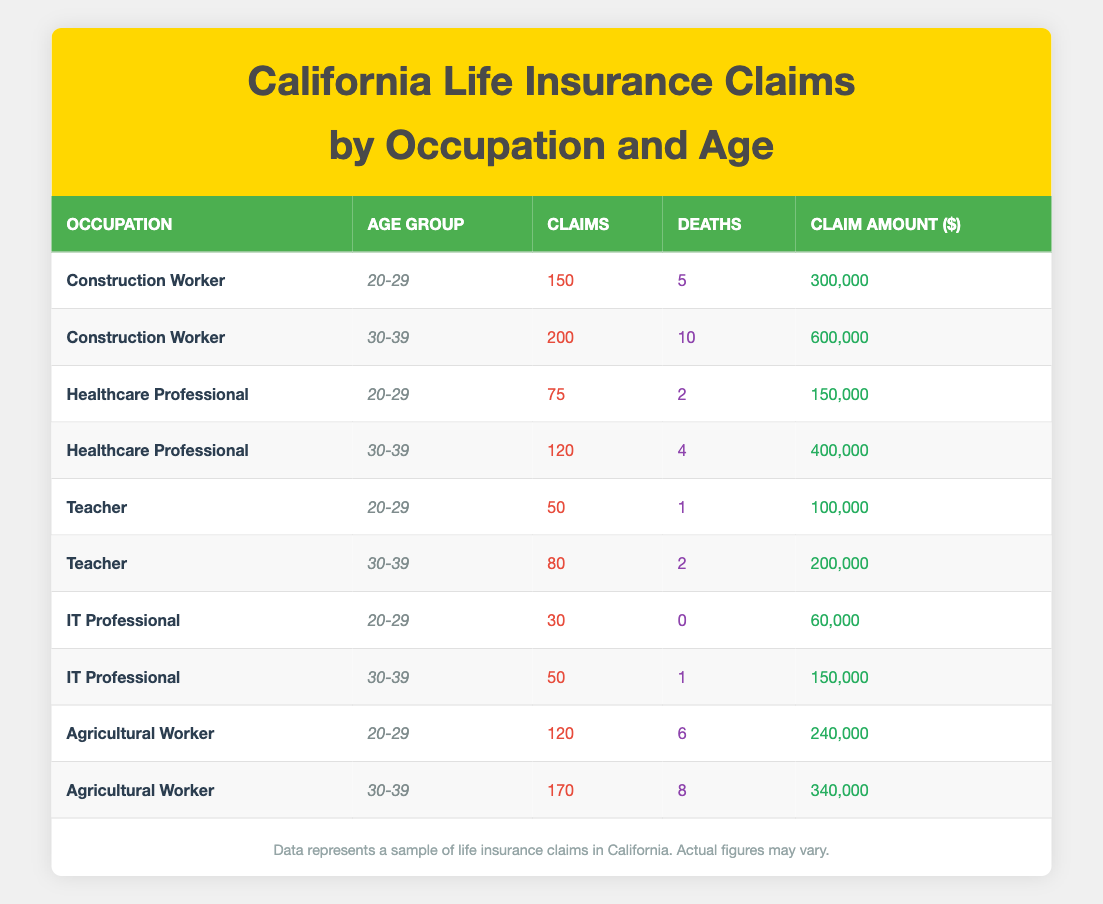What is the total claim amount for Construction Workers aged 30-39? There is only one entry for Construction Workers aged 30-39 with a claim amount of 600,000. Thus, the total claim amount for this category is simply 600,000.
Answer: 600000 In which age group did Agricultural Workers have the highest number of claims? Comparing the two age groups for Agricultural Workers, 120 claims were recorded for the 20-29 age group and 170 claims for the 30-39 age group. Therefore, they had the highest number of claims in the 30-39 age group.
Answer: 30-39 What is the average claim amount for Healthcare Professionals across both age groups? The claim amounts for Healthcare Professionals are 150,000 for the 20-29 age group and 400,000 for the 30-39 age group. Adding these two amounts gives 150,000 + 400,000 = 550,000. There are two data points, so the average is 550,000 / 2 = 275,000.
Answer: 275000 True or False: IT Professionals aged 20-29 had any deaths recorded in their claims. Referring to the data, IT Professionals aged 20-29 have 0 deaths recorded. Therefore, the statement is false.
Answer: False How many claims were made by Teachers aged 30-39 compared to Agricultural Workers aged 30-39? Teachers aged 30-39 had 80 claims, while Agricultural Workers aged 30-39 had 170 claims. To compare, 170 is greater than 80, indicating that Agricultural Workers had more claims in that age group.
Answer: Agricultural Workers had more claims What is the total number of deaths among Agricultural Workers and Construction Workers combined? For Agricultural Workers, there were 6 deaths in the 20-29 age group and 8 deaths in the 30-39 age group, totaling 6 + 8 = 14 deaths. For Construction Workers, there were 5 deaths in the 20-29 age group and 10 deaths in the 30-39 age group, totaling 5 + 10 = 15 deaths. Adding both totals gives 14 + 15 = 29 deaths combined.
Answer: 29 What is the ratio of claims to deaths for Healthcare Professionals aged 30-39? For Healthcare Professionals aged 30-39, there were 120 claims and 4 deaths. To find the ratio, divide the number of claims (120) by the number of deaths (4), which gives a ratio of 120 / 4 = 30.
Answer: 30 Which occupation had the lowest number of claims in the age group 20-29? Reviewing the claims in the 20-29 age group, Teachers had 50 claims, IT Professionals had 30 claims, Healthcare Professionals had 75 claims, Agricultural Workers had 120 claims, and Construction Workers had 150 claims. Thus, the occupation with the lowest claims in this age group is IT Professionals with 30 claims.
Answer: IT Professionals 